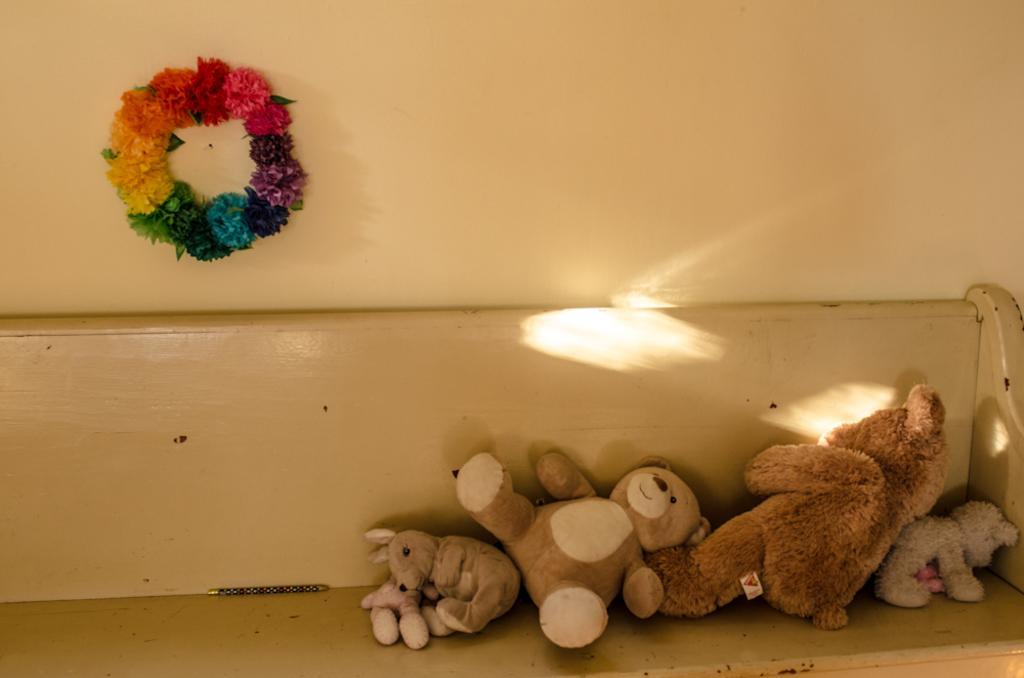Please provide a concise description of this image. In this image, I can see the teddy bears and toys, which are on a bench. This looks like a colorful wreath, which is attached to a wall. 